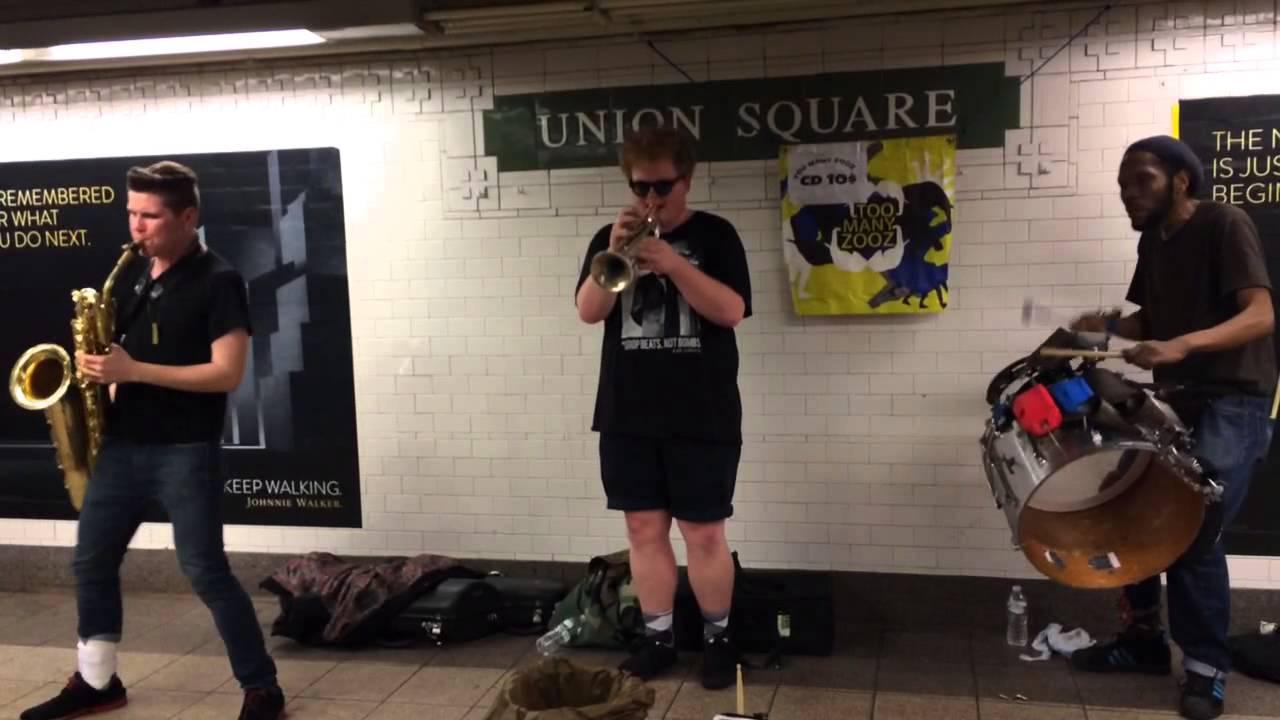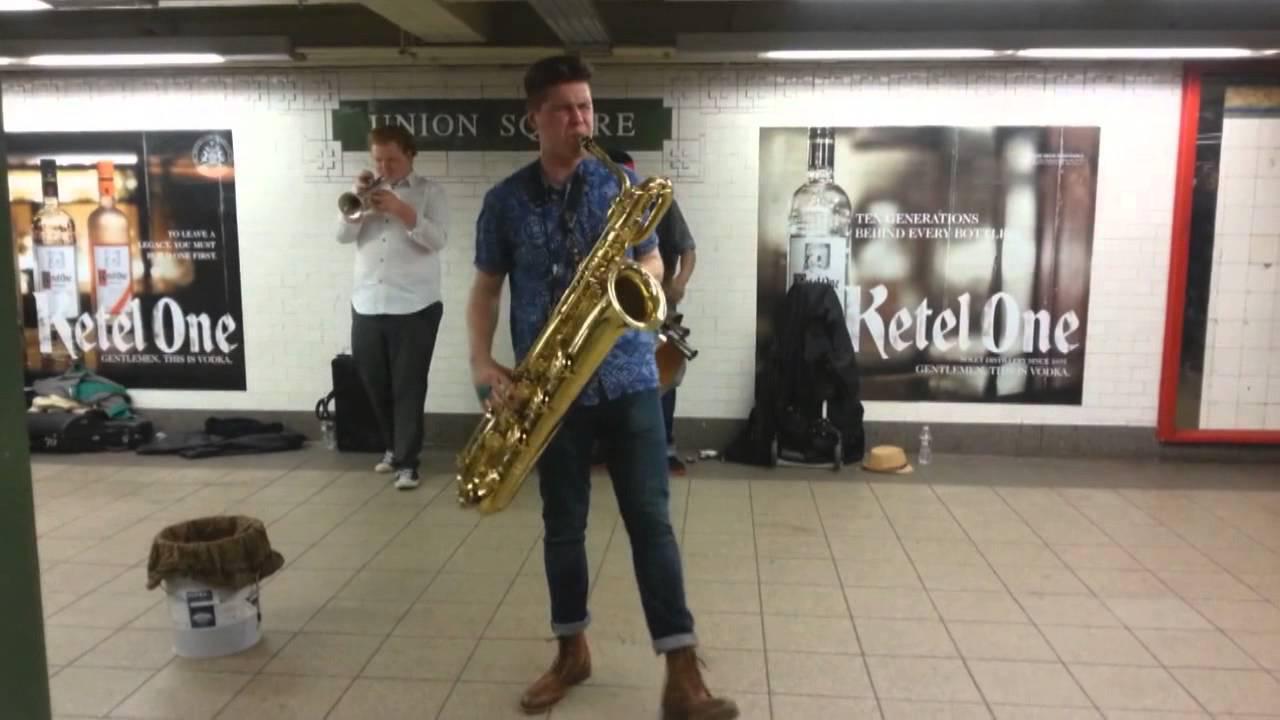The first image is the image on the left, the second image is the image on the right. Given the left and right images, does the statement "There are three men playing instrument in the subway with two of them where rlong black pants." hold true? Answer yes or no. No. The first image is the image on the left, the second image is the image on the right. Assess this claim about the two images: "The right image includes a sax player, drummer and horn player standing in a station with images of liquor bottles behind them and a bucket-type container on the floor by them.". Correct or not? Answer yes or no. No. 